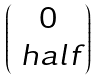<formula> <loc_0><loc_0><loc_500><loc_500>\begin{pmatrix} 0 \\ \ h a l f \end{pmatrix}</formula> 